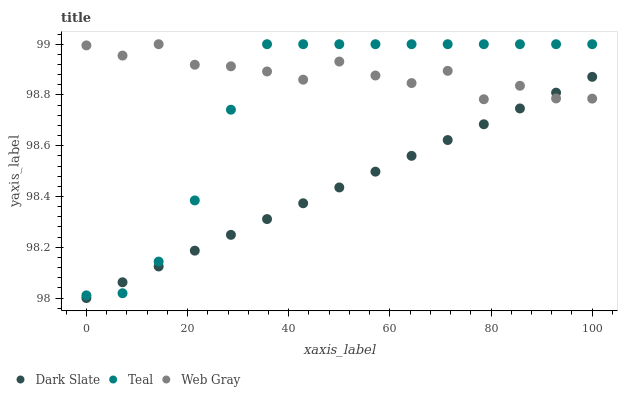Does Dark Slate have the minimum area under the curve?
Answer yes or no. Yes. Does Web Gray have the maximum area under the curve?
Answer yes or no. Yes. Does Teal have the minimum area under the curve?
Answer yes or no. No. Does Teal have the maximum area under the curve?
Answer yes or no. No. Is Dark Slate the smoothest?
Answer yes or no. Yes. Is Web Gray the roughest?
Answer yes or no. Yes. Is Teal the smoothest?
Answer yes or no. No. Is Teal the roughest?
Answer yes or no. No. Does Dark Slate have the lowest value?
Answer yes or no. Yes. Does Teal have the lowest value?
Answer yes or no. No. Does Teal have the highest value?
Answer yes or no. Yes. Does Dark Slate intersect Teal?
Answer yes or no. Yes. Is Dark Slate less than Teal?
Answer yes or no. No. Is Dark Slate greater than Teal?
Answer yes or no. No. 